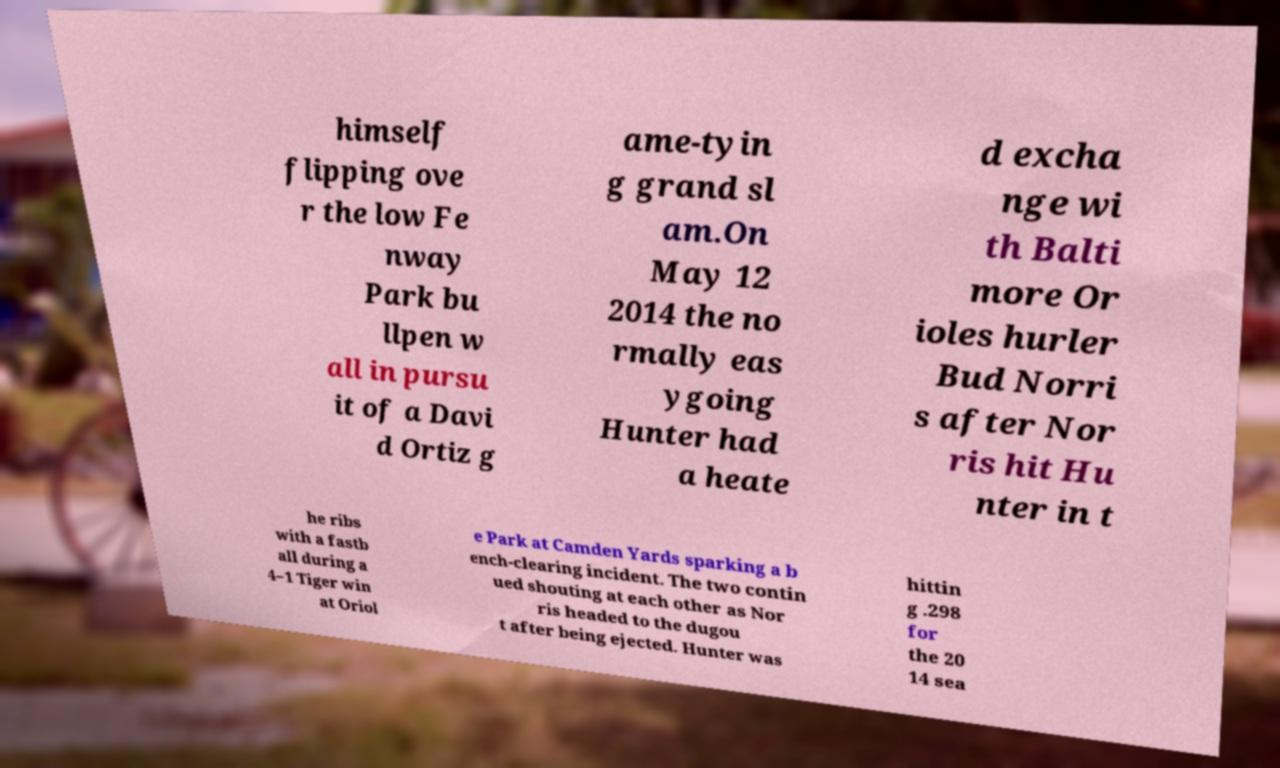There's text embedded in this image that I need extracted. Can you transcribe it verbatim? himself flipping ove r the low Fe nway Park bu llpen w all in pursu it of a Davi d Ortiz g ame-tyin g grand sl am.On May 12 2014 the no rmally eas ygoing Hunter had a heate d excha nge wi th Balti more Or ioles hurler Bud Norri s after Nor ris hit Hu nter in t he ribs with a fastb all during a 4–1 Tiger win at Oriol e Park at Camden Yards sparking a b ench-clearing incident. The two contin ued shouting at each other as Nor ris headed to the dugou t after being ejected. Hunter was hittin g .298 for the 20 14 sea 